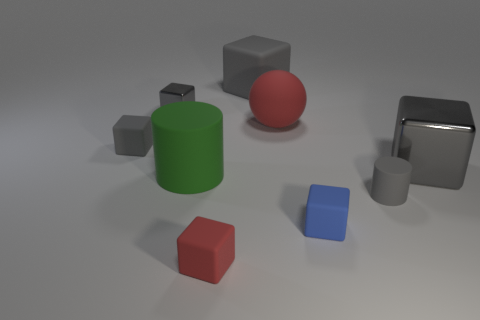How many gray cubes must be subtracted to get 1 gray cubes? 3 Subtract all blue spheres. How many gray blocks are left? 4 Subtract all red blocks. How many blocks are left? 5 Subtract all big gray blocks. How many blocks are left? 4 Subtract 1 blocks. How many blocks are left? 5 Subtract all yellow blocks. Subtract all gray balls. How many blocks are left? 6 Add 1 tiny matte blocks. How many objects exist? 10 Subtract all balls. How many objects are left? 8 Add 2 spheres. How many spheres exist? 3 Subtract 0 green blocks. How many objects are left? 9 